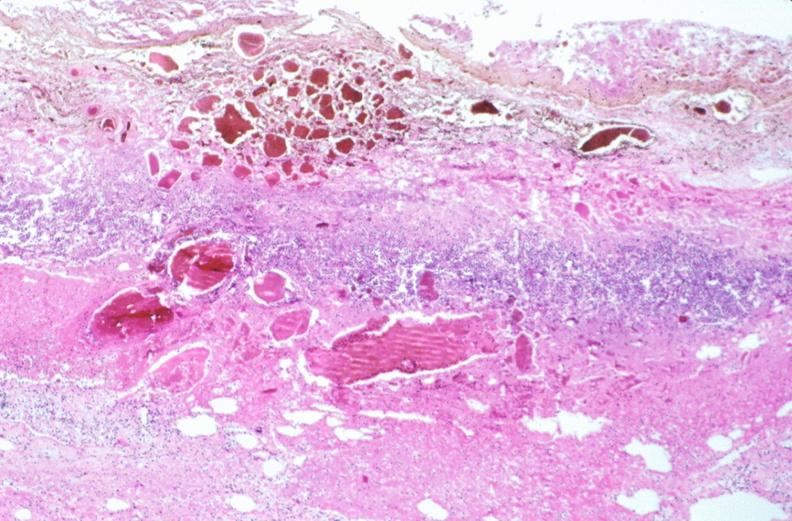does this image show stomach, necrotizing esophagitis and gastritis, sulfuric acid ingested as suicide attempt?
Answer the question using a single word or phrase. Yes 